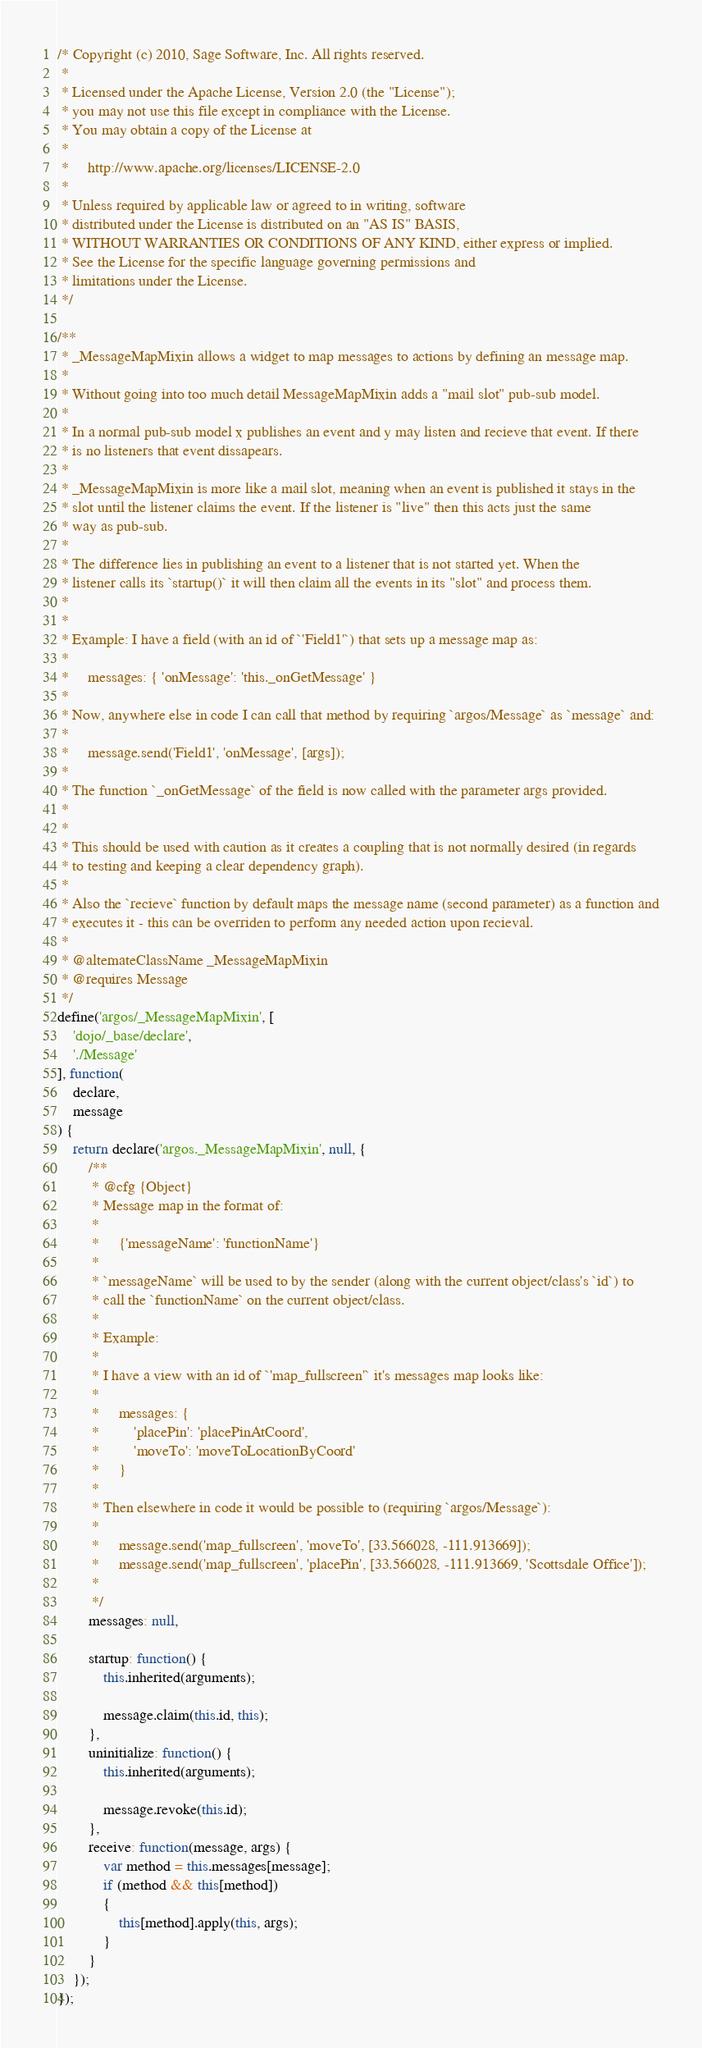Convert code to text. <code><loc_0><loc_0><loc_500><loc_500><_JavaScript_>/* Copyright (c) 2010, Sage Software, Inc. All rights reserved.
 *
 * Licensed under the Apache License, Version 2.0 (the "License");
 * you may not use this file except in compliance with the License.
 * You may obtain a copy of the License at
 *
 *     http://www.apache.org/licenses/LICENSE-2.0
 *
 * Unless required by applicable law or agreed to in writing, software
 * distributed under the License is distributed on an "AS IS" BASIS,
 * WITHOUT WARRANTIES OR CONDITIONS OF ANY KIND, either express or implied.
 * See the License for the specific language governing permissions and
 * limitations under the License.
 */

/**
 * _MessageMapMixin allows a widget to map messages to actions by defining an message map.
 *
 * Without going into too much detail MessageMapMixin adds a "mail slot" pub-sub model.
 *
 * In a normal pub-sub model x publishes an event and y may listen and recieve that event. If there
 * is no listeners that event dissapears.
 *
 * _MessageMapMixin is more like a mail slot, meaning when an event is published it stays in the
 * slot until the listener claims the event. If the listener is "live" then this acts just the same
 * way as pub-sub.
 *
 * The difference lies in publishing an event to a listener that is not started yet. When the
 * listener calls its `startup()` it will then claim all the events in its "slot" and process them.
 *
 *
 * Example: I have a field (with an id of `'Field1'`) that sets up a message map as:
 *
 *     messages: { 'onMessage': 'this._onGetMessage' }
 *
 * Now, anywhere else in code I can call that method by requiring `argos/Message` as `message` and:
 *
 *     message.send('Field1', 'onMessage', [args]);
 *
 * The function `_onGetMessage` of the field is now called with the parameter args provided.
 *
 *
 * This should be used with caution as it creates a coupling that is not normally desired (in regards
 * to testing and keeping a clear dependency graph).
 *
 * Also the `recieve` function by default maps the message name (second parameter) as a function and
 * executes it - this can be overriden to perform any needed action upon recieval.
 *
 * @alternateClassName _MessageMapMixin
 * @requires Message
 */
define('argos/_MessageMapMixin', [
    'dojo/_base/declare',
    './Message'
], function(
    declare,
    message
) {
    return declare('argos._MessageMapMixin', null, {
        /**
         * @cfg {Object}
         * Message map in the format of:
         *
         *     {'messageName': 'functionName'}
         *
         * `messageName` will be used to by the sender (along with the current object/class's `id`) to
         * call the `functionName` on the current object/class.
         *
         * Example:
         *
         * I have a view with an id of `'map_fullscreen'` it's messages map looks like:
         *
         *     messages: {
         *         'placePin': 'placePinAtCoord',
         *         'moveTo': 'moveToLocationByCoord'
         *     }
         *
         * Then elsewhere in code it would be possible to (requiring `argos/Message`):
         *
         *     message.send('map_fullscreen', 'moveTo', [33.566028, -111.913669]);
         *     message.send('map_fullscreen', 'placePin', [33.566028, -111.913669, 'Scottsdale Office']);
         *
         */
        messages: null,

        startup: function() {
            this.inherited(arguments);

            message.claim(this.id, this);
        },
        uninitialize: function() {
            this.inherited(arguments);

            message.revoke(this.id);
        },
        receive: function(message, args) {
            var method = this.messages[message];
            if (method && this[method])
            {
                this[method].apply(this, args);
            }
        }
    });
});</code> 